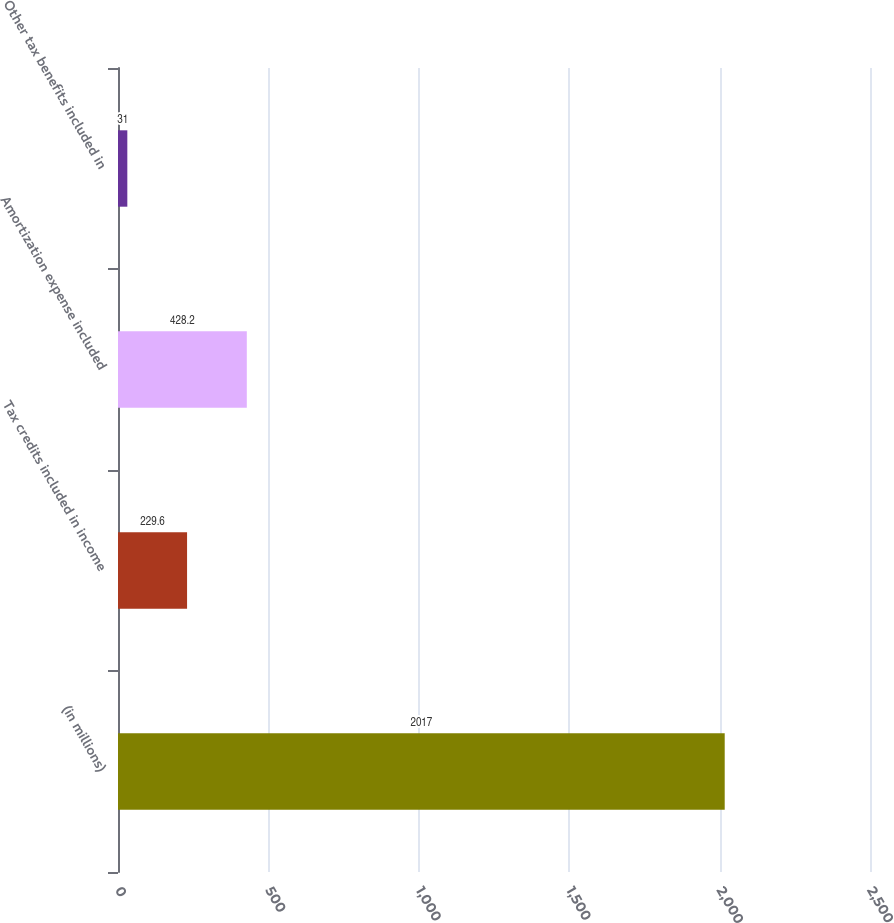Convert chart to OTSL. <chart><loc_0><loc_0><loc_500><loc_500><bar_chart><fcel>(in millions)<fcel>Tax credits included in income<fcel>Amortization expense included<fcel>Other tax benefits included in<nl><fcel>2017<fcel>229.6<fcel>428.2<fcel>31<nl></chart> 